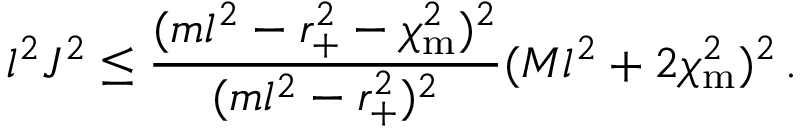<formula> <loc_0><loc_0><loc_500><loc_500>l ^ { 2 } J ^ { 2 } \leq \frac { ( m l ^ { 2 } - r _ { + } ^ { 2 } - \chi _ { m } ^ { 2 } ) ^ { 2 } } { ( m l ^ { 2 } - r _ { + } ^ { 2 } ) ^ { 2 } } ( M l ^ { 2 } + 2 \chi _ { m } ^ { 2 } ) ^ { 2 } \, .</formula> 